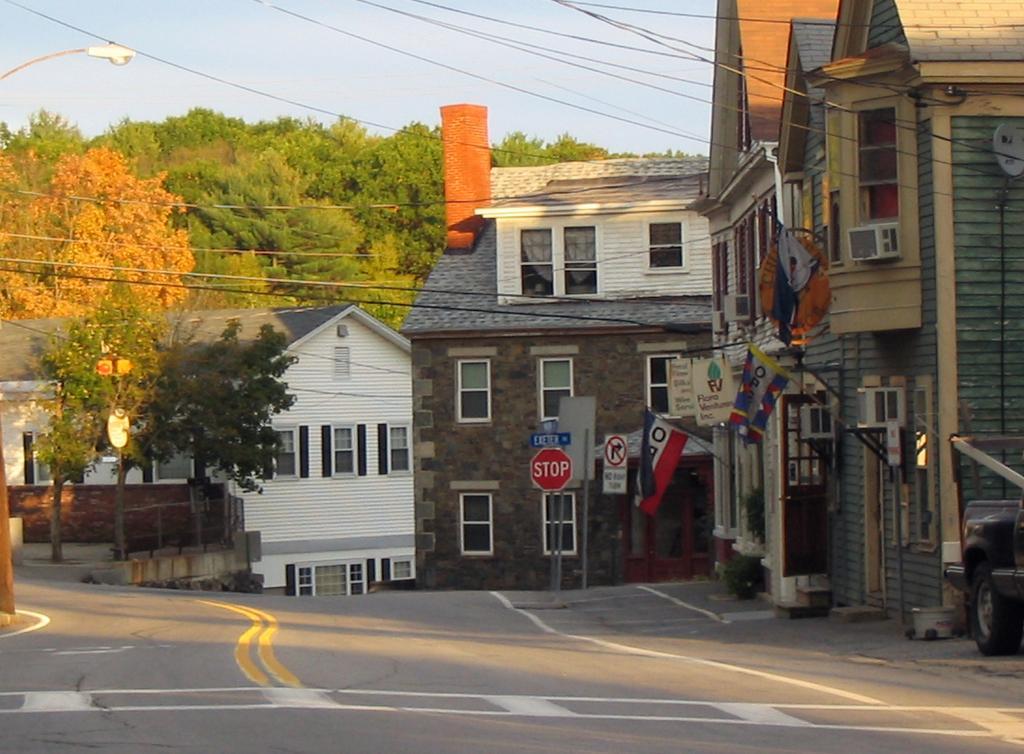Describe this image in one or two sentences. In this picture I can see the road at the bottom, there are boards and buildings in the middle, in the background I can see few trees. At the top there is the sky. 